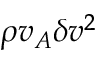Convert formula to latex. <formula><loc_0><loc_0><loc_500><loc_500>\rho v _ { A } \delta v ^ { 2 }</formula> 